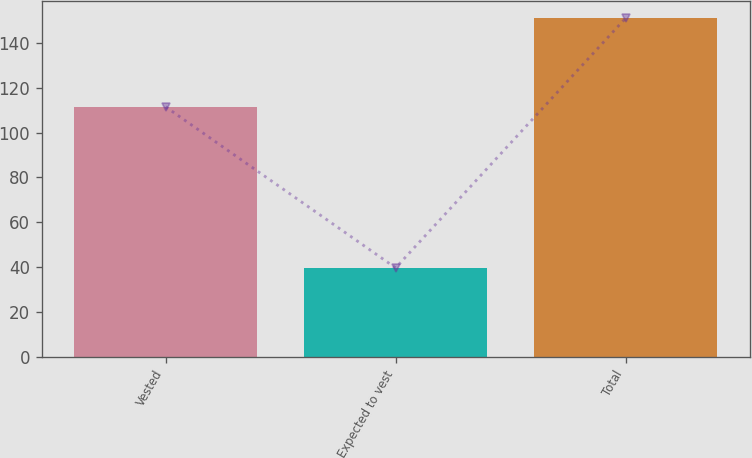Convert chart to OTSL. <chart><loc_0><loc_0><loc_500><loc_500><bar_chart><fcel>Vested<fcel>Expected to vest<fcel>Total<nl><fcel>111.5<fcel>39.6<fcel>151.1<nl></chart> 